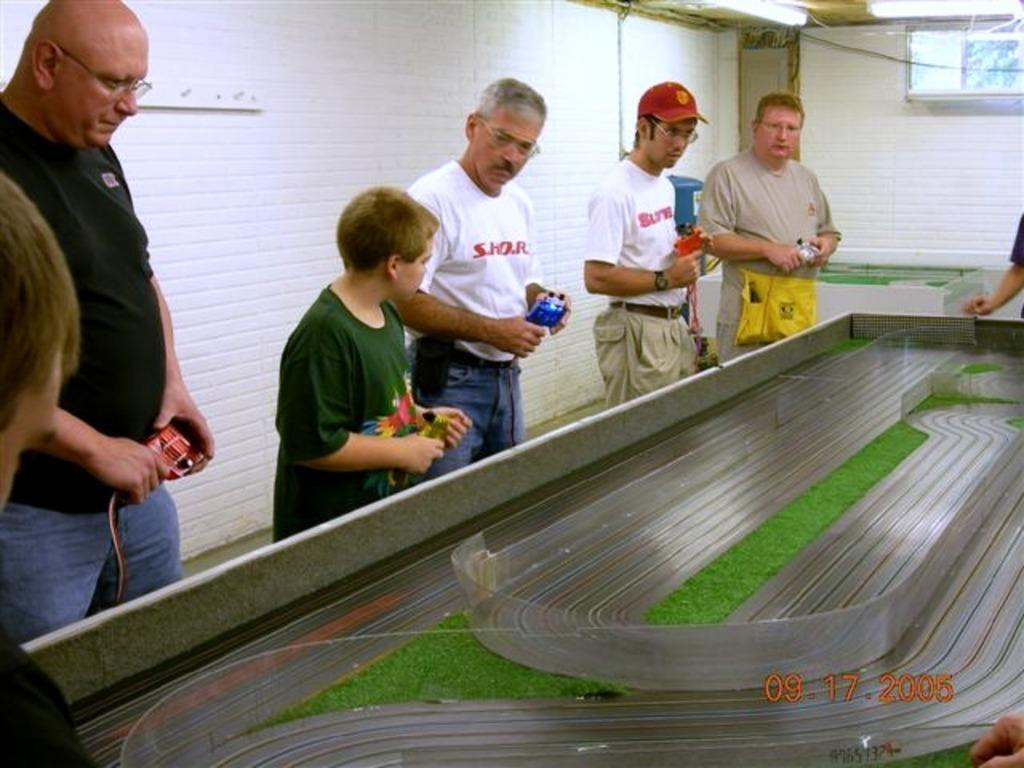How many people are present in the image? There are multiple people in the image. What are the people doing in the image? The people are standing in front of a table. What are the people holding in their hands? The people are holding something in their hands. What can be seen in the background of the image? There is a wall visible in the background of the image. What type of plants can be seen growing on the table in the image? There are no plants visible on the table in the image. Is there a baseball game happening in the image? There is no indication of a baseball game in the image. 